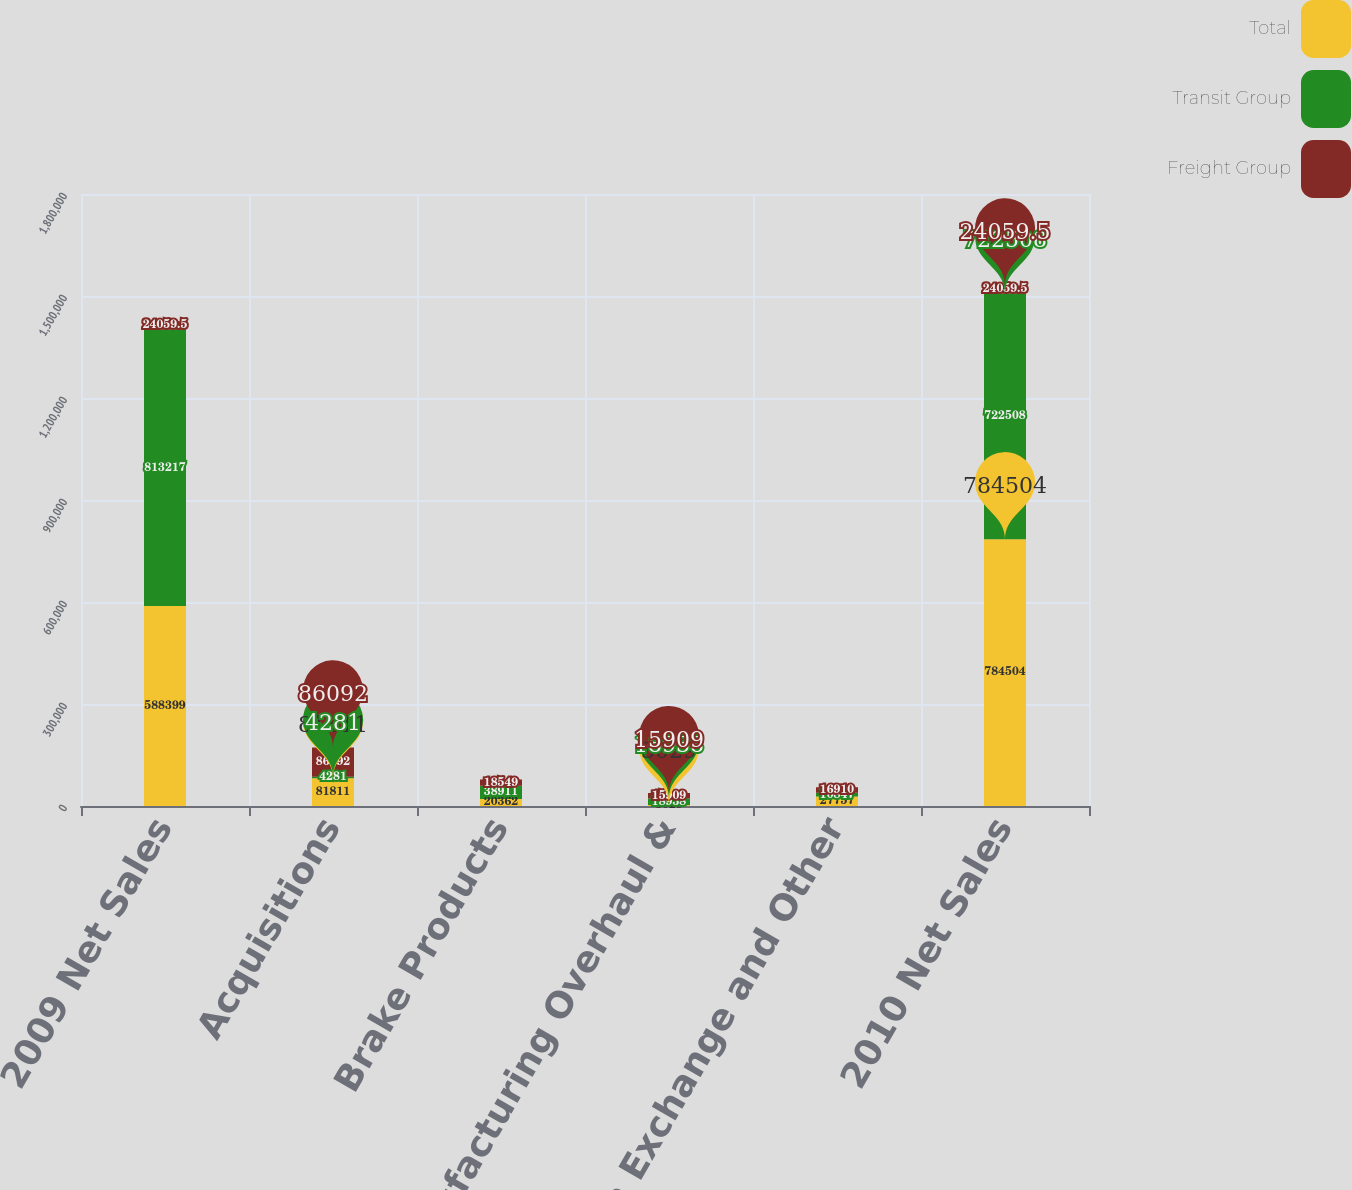<chart> <loc_0><loc_0><loc_500><loc_500><stacked_bar_chart><ecel><fcel>2009 Net Sales<fcel>Acquisitions<fcel>Brake Products<fcel>Remanufacturing Overhaul &<fcel>Foreign Exchange and Other<fcel>2010 Net Sales<nl><fcel>Total<fcel>588399<fcel>81811<fcel>20362<fcel>3029<fcel>27757<fcel>784504<nl><fcel>Transit Group<fcel>813217<fcel>4281<fcel>38911<fcel>18938<fcel>10847<fcel>722508<nl><fcel>Freight Group<fcel>24059.5<fcel>86092<fcel>18549<fcel>15909<fcel>16910<fcel>24059.5<nl></chart> 